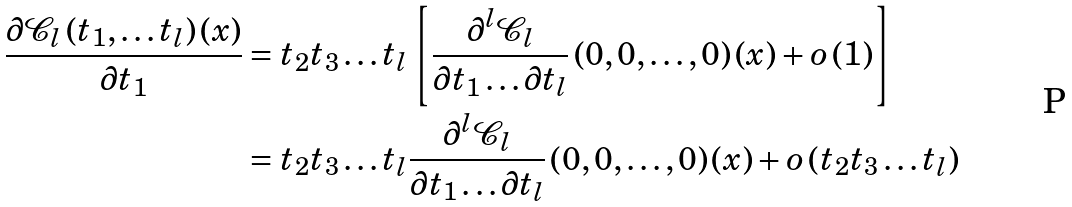<formula> <loc_0><loc_0><loc_500><loc_500>\frac { \partial \mathcal { C } _ { l } \left ( t _ { 1 } , \dots t _ { l } \right ) \left ( x \right ) } { \partial t _ { 1 } } & = t _ { 2 } t _ { 3 } \dots t _ { l } \left [ \frac { \partial ^ { l } \mathcal { C } _ { l } } { \partial t _ { 1 } \dots \partial t _ { l } } \left ( 0 , 0 , \dots , 0 \right ) \left ( x \right ) + o \left ( 1 \right ) \right ] \\ & = t _ { 2 } t _ { 3 } \dots t _ { l } \frac { \partial ^ { l } \mathcal { C } _ { l } } { \partial t _ { 1 } \dots \partial t _ { l } } \left ( 0 , 0 , \dots , 0 \right ) \left ( x \right ) + o \left ( t _ { 2 } t _ { 3 } \dots t _ { l } \right )</formula> 